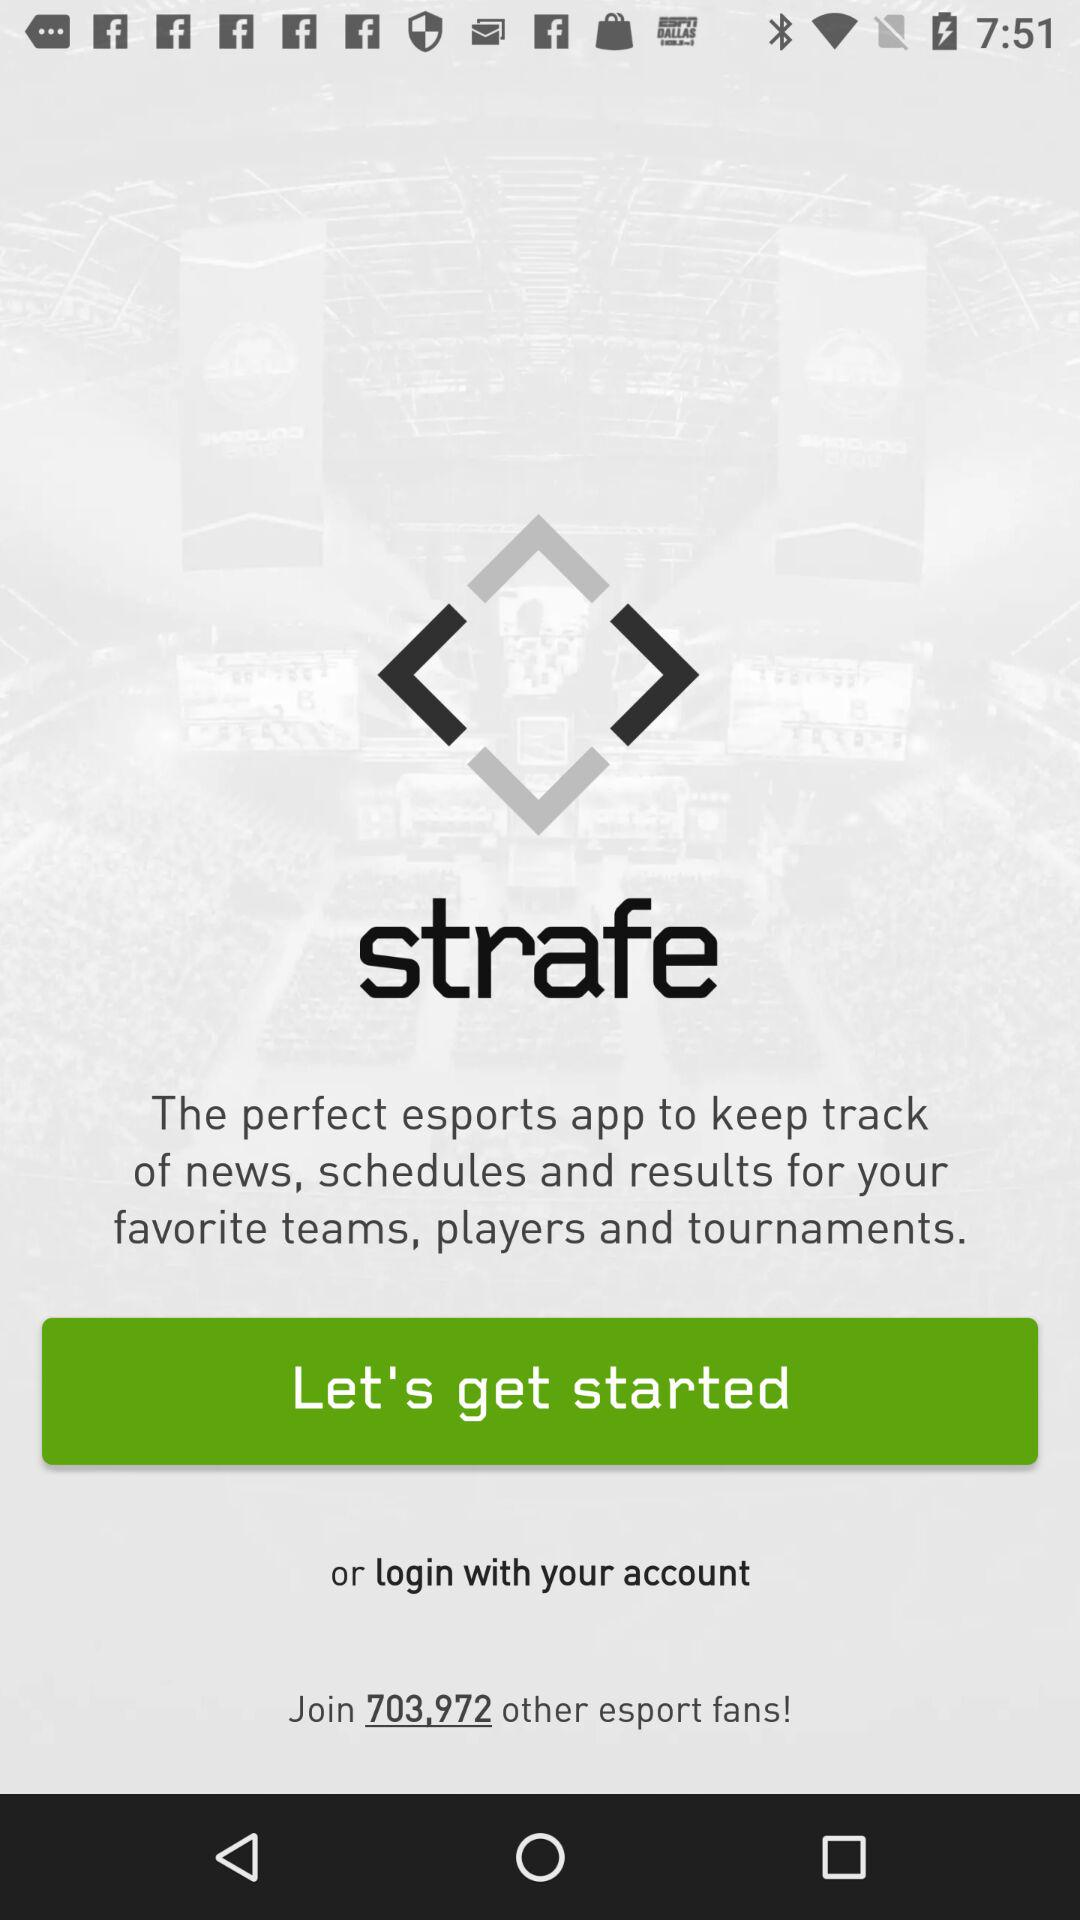What is the application name? The application name is "strafe". 